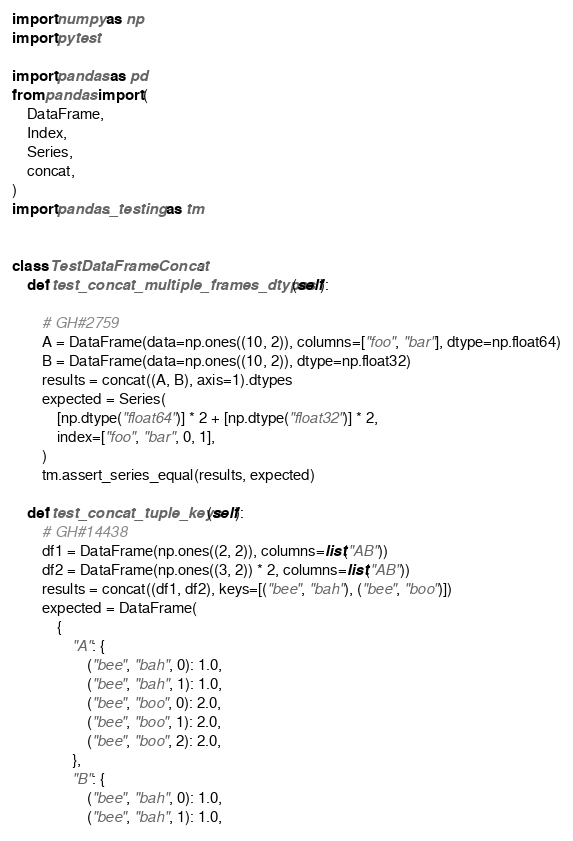Convert code to text. <code><loc_0><loc_0><loc_500><loc_500><_Python_>import numpy as np
import pytest

import pandas as pd
from pandas import (
    DataFrame,
    Index,
    Series,
    concat,
)
import pandas._testing as tm


class TestDataFrameConcat:
    def test_concat_multiple_frames_dtypes(self):

        # GH#2759
        A = DataFrame(data=np.ones((10, 2)), columns=["foo", "bar"], dtype=np.float64)
        B = DataFrame(data=np.ones((10, 2)), dtype=np.float32)
        results = concat((A, B), axis=1).dtypes
        expected = Series(
            [np.dtype("float64")] * 2 + [np.dtype("float32")] * 2,
            index=["foo", "bar", 0, 1],
        )
        tm.assert_series_equal(results, expected)

    def test_concat_tuple_keys(self):
        # GH#14438
        df1 = DataFrame(np.ones((2, 2)), columns=list("AB"))
        df2 = DataFrame(np.ones((3, 2)) * 2, columns=list("AB"))
        results = concat((df1, df2), keys=[("bee", "bah"), ("bee", "boo")])
        expected = DataFrame(
            {
                "A": {
                    ("bee", "bah", 0): 1.0,
                    ("bee", "bah", 1): 1.0,
                    ("bee", "boo", 0): 2.0,
                    ("bee", "boo", 1): 2.0,
                    ("bee", "boo", 2): 2.0,
                },
                "B": {
                    ("bee", "bah", 0): 1.0,
                    ("bee", "bah", 1): 1.0,</code> 